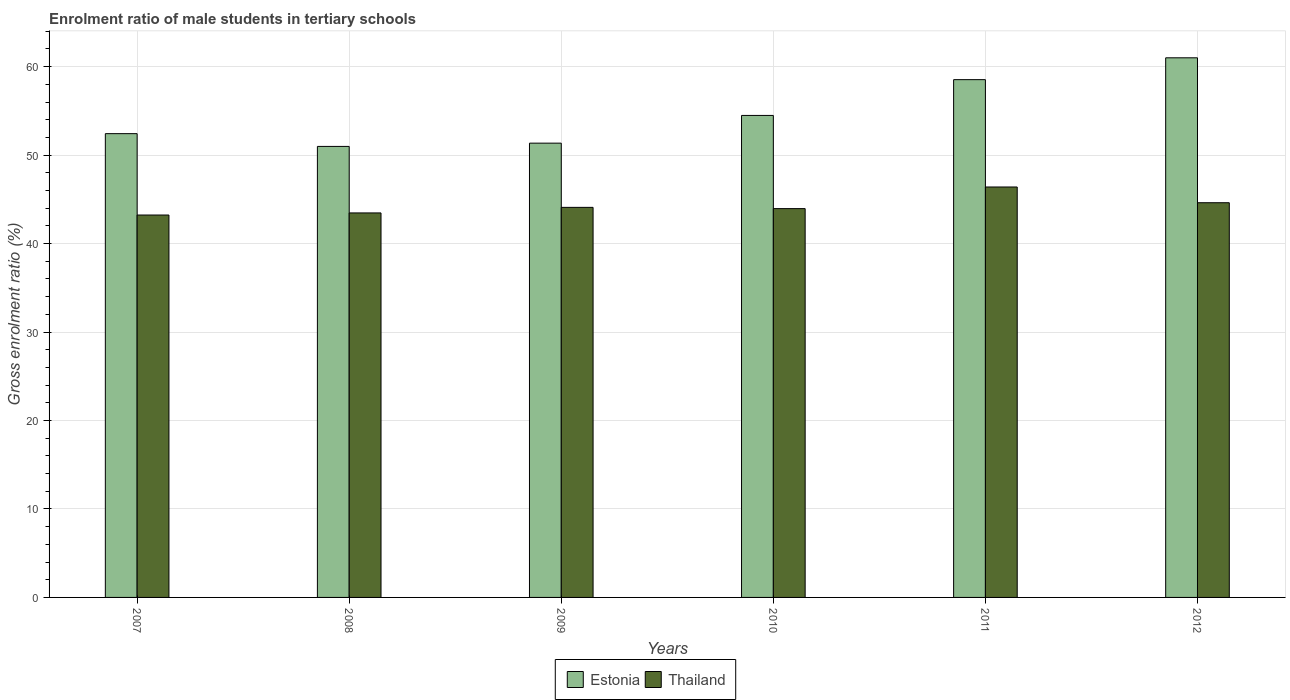How many different coloured bars are there?
Offer a very short reply. 2. Are the number of bars per tick equal to the number of legend labels?
Offer a very short reply. Yes. How many bars are there on the 5th tick from the left?
Offer a very short reply. 2. What is the enrolment ratio of male students in tertiary schools in Thailand in 2012?
Your answer should be very brief. 44.62. Across all years, what is the maximum enrolment ratio of male students in tertiary schools in Thailand?
Your answer should be compact. 46.4. Across all years, what is the minimum enrolment ratio of male students in tertiary schools in Estonia?
Provide a succinct answer. 50.98. In which year was the enrolment ratio of male students in tertiary schools in Thailand maximum?
Offer a terse response. 2011. In which year was the enrolment ratio of male students in tertiary schools in Estonia minimum?
Keep it short and to the point. 2008. What is the total enrolment ratio of male students in tertiary schools in Estonia in the graph?
Ensure brevity in your answer.  328.78. What is the difference between the enrolment ratio of male students in tertiary schools in Estonia in 2008 and that in 2009?
Give a very brief answer. -0.37. What is the difference between the enrolment ratio of male students in tertiary schools in Thailand in 2007 and the enrolment ratio of male students in tertiary schools in Estonia in 2010?
Your answer should be very brief. -11.26. What is the average enrolment ratio of male students in tertiary schools in Thailand per year?
Keep it short and to the point. 44.29. In the year 2011, what is the difference between the enrolment ratio of male students in tertiary schools in Thailand and enrolment ratio of male students in tertiary schools in Estonia?
Provide a succinct answer. -12.13. What is the ratio of the enrolment ratio of male students in tertiary schools in Thailand in 2007 to that in 2010?
Keep it short and to the point. 0.98. Is the enrolment ratio of male students in tertiary schools in Thailand in 2007 less than that in 2011?
Provide a succinct answer. Yes. Is the difference between the enrolment ratio of male students in tertiary schools in Thailand in 2009 and 2011 greater than the difference between the enrolment ratio of male students in tertiary schools in Estonia in 2009 and 2011?
Offer a terse response. Yes. What is the difference between the highest and the second highest enrolment ratio of male students in tertiary schools in Estonia?
Give a very brief answer. 2.47. What is the difference between the highest and the lowest enrolment ratio of male students in tertiary schools in Thailand?
Give a very brief answer. 3.17. In how many years, is the enrolment ratio of male students in tertiary schools in Thailand greater than the average enrolment ratio of male students in tertiary schools in Thailand taken over all years?
Give a very brief answer. 2. Is the sum of the enrolment ratio of male students in tertiary schools in Thailand in 2008 and 2011 greater than the maximum enrolment ratio of male students in tertiary schools in Estonia across all years?
Your answer should be compact. Yes. What does the 2nd bar from the left in 2007 represents?
Make the answer very short. Thailand. What does the 2nd bar from the right in 2010 represents?
Keep it short and to the point. Estonia. How many bars are there?
Provide a short and direct response. 12. What is the difference between two consecutive major ticks on the Y-axis?
Provide a short and direct response. 10. Are the values on the major ticks of Y-axis written in scientific E-notation?
Make the answer very short. No. Where does the legend appear in the graph?
Provide a succinct answer. Bottom center. How many legend labels are there?
Your response must be concise. 2. What is the title of the graph?
Keep it short and to the point. Enrolment ratio of male students in tertiary schools. What is the label or title of the X-axis?
Provide a short and direct response. Years. What is the label or title of the Y-axis?
Your answer should be compact. Gross enrolment ratio (%). What is the Gross enrolment ratio (%) of Estonia in 2007?
Provide a succinct answer. 52.43. What is the Gross enrolment ratio (%) of Thailand in 2007?
Make the answer very short. 43.23. What is the Gross enrolment ratio (%) in Estonia in 2008?
Keep it short and to the point. 50.98. What is the Gross enrolment ratio (%) of Thailand in 2008?
Offer a very short reply. 43.47. What is the Gross enrolment ratio (%) of Estonia in 2009?
Your answer should be compact. 51.35. What is the Gross enrolment ratio (%) in Thailand in 2009?
Offer a very short reply. 44.09. What is the Gross enrolment ratio (%) in Estonia in 2010?
Offer a terse response. 54.49. What is the Gross enrolment ratio (%) in Thailand in 2010?
Make the answer very short. 43.95. What is the Gross enrolment ratio (%) of Estonia in 2011?
Your answer should be compact. 58.53. What is the Gross enrolment ratio (%) of Thailand in 2011?
Your answer should be compact. 46.4. What is the Gross enrolment ratio (%) of Estonia in 2012?
Your answer should be very brief. 61. What is the Gross enrolment ratio (%) in Thailand in 2012?
Give a very brief answer. 44.62. Across all years, what is the maximum Gross enrolment ratio (%) in Estonia?
Your answer should be compact. 61. Across all years, what is the maximum Gross enrolment ratio (%) of Thailand?
Make the answer very short. 46.4. Across all years, what is the minimum Gross enrolment ratio (%) of Estonia?
Your response must be concise. 50.98. Across all years, what is the minimum Gross enrolment ratio (%) of Thailand?
Offer a terse response. 43.23. What is the total Gross enrolment ratio (%) in Estonia in the graph?
Offer a terse response. 328.78. What is the total Gross enrolment ratio (%) in Thailand in the graph?
Give a very brief answer. 265.75. What is the difference between the Gross enrolment ratio (%) in Estonia in 2007 and that in 2008?
Your response must be concise. 1.44. What is the difference between the Gross enrolment ratio (%) of Thailand in 2007 and that in 2008?
Provide a short and direct response. -0.24. What is the difference between the Gross enrolment ratio (%) of Estonia in 2007 and that in 2009?
Ensure brevity in your answer.  1.07. What is the difference between the Gross enrolment ratio (%) in Thailand in 2007 and that in 2009?
Provide a succinct answer. -0.87. What is the difference between the Gross enrolment ratio (%) of Estonia in 2007 and that in 2010?
Keep it short and to the point. -2.06. What is the difference between the Gross enrolment ratio (%) in Thailand in 2007 and that in 2010?
Provide a succinct answer. -0.73. What is the difference between the Gross enrolment ratio (%) of Estonia in 2007 and that in 2011?
Your answer should be very brief. -6.1. What is the difference between the Gross enrolment ratio (%) in Thailand in 2007 and that in 2011?
Provide a succinct answer. -3.17. What is the difference between the Gross enrolment ratio (%) in Estonia in 2007 and that in 2012?
Offer a very short reply. -8.57. What is the difference between the Gross enrolment ratio (%) of Thailand in 2007 and that in 2012?
Offer a very short reply. -1.39. What is the difference between the Gross enrolment ratio (%) in Estonia in 2008 and that in 2009?
Your answer should be very brief. -0.37. What is the difference between the Gross enrolment ratio (%) in Thailand in 2008 and that in 2009?
Give a very brief answer. -0.63. What is the difference between the Gross enrolment ratio (%) of Estonia in 2008 and that in 2010?
Your answer should be compact. -3.5. What is the difference between the Gross enrolment ratio (%) in Thailand in 2008 and that in 2010?
Give a very brief answer. -0.49. What is the difference between the Gross enrolment ratio (%) in Estonia in 2008 and that in 2011?
Offer a very short reply. -7.55. What is the difference between the Gross enrolment ratio (%) of Thailand in 2008 and that in 2011?
Your response must be concise. -2.93. What is the difference between the Gross enrolment ratio (%) of Estonia in 2008 and that in 2012?
Your answer should be very brief. -10.02. What is the difference between the Gross enrolment ratio (%) of Thailand in 2008 and that in 2012?
Your response must be concise. -1.15. What is the difference between the Gross enrolment ratio (%) of Estonia in 2009 and that in 2010?
Ensure brevity in your answer.  -3.13. What is the difference between the Gross enrolment ratio (%) in Thailand in 2009 and that in 2010?
Offer a very short reply. 0.14. What is the difference between the Gross enrolment ratio (%) in Estonia in 2009 and that in 2011?
Your response must be concise. -7.18. What is the difference between the Gross enrolment ratio (%) of Thailand in 2009 and that in 2011?
Provide a succinct answer. -2.3. What is the difference between the Gross enrolment ratio (%) in Estonia in 2009 and that in 2012?
Offer a very short reply. -9.65. What is the difference between the Gross enrolment ratio (%) of Thailand in 2009 and that in 2012?
Offer a very short reply. -0.53. What is the difference between the Gross enrolment ratio (%) in Estonia in 2010 and that in 2011?
Your answer should be very brief. -4.04. What is the difference between the Gross enrolment ratio (%) of Thailand in 2010 and that in 2011?
Ensure brevity in your answer.  -2.44. What is the difference between the Gross enrolment ratio (%) of Estonia in 2010 and that in 2012?
Give a very brief answer. -6.51. What is the difference between the Gross enrolment ratio (%) of Thailand in 2010 and that in 2012?
Keep it short and to the point. -0.67. What is the difference between the Gross enrolment ratio (%) in Estonia in 2011 and that in 2012?
Provide a short and direct response. -2.47. What is the difference between the Gross enrolment ratio (%) of Thailand in 2011 and that in 2012?
Give a very brief answer. 1.78. What is the difference between the Gross enrolment ratio (%) in Estonia in 2007 and the Gross enrolment ratio (%) in Thailand in 2008?
Ensure brevity in your answer.  8.96. What is the difference between the Gross enrolment ratio (%) in Estonia in 2007 and the Gross enrolment ratio (%) in Thailand in 2009?
Keep it short and to the point. 8.33. What is the difference between the Gross enrolment ratio (%) of Estonia in 2007 and the Gross enrolment ratio (%) of Thailand in 2010?
Your answer should be compact. 8.47. What is the difference between the Gross enrolment ratio (%) of Estonia in 2007 and the Gross enrolment ratio (%) of Thailand in 2011?
Your response must be concise. 6.03. What is the difference between the Gross enrolment ratio (%) of Estonia in 2007 and the Gross enrolment ratio (%) of Thailand in 2012?
Offer a very short reply. 7.81. What is the difference between the Gross enrolment ratio (%) in Estonia in 2008 and the Gross enrolment ratio (%) in Thailand in 2009?
Keep it short and to the point. 6.89. What is the difference between the Gross enrolment ratio (%) in Estonia in 2008 and the Gross enrolment ratio (%) in Thailand in 2010?
Keep it short and to the point. 7.03. What is the difference between the Gross enrolment ratio (%) in Estonia in 2008 and the Gross enrolment ratio (%) in Thailand in 2011?
Your response must be concise. 4.59. What is the difference between the Gross enrolment ratio (%) in Estonia in 2008 and the Gross enrolment ratio (%) in Thailand in 2012?
Ensure brevity in your answer.  6.37. What is the difference between the Gross enrolment ratio (%) of Estonia in 2009 and the Gross enrolment ratio (%) of Thailand in 2010?
Offer a terse response. 7.4. What is the difference between the Gross enrolment ratio (%) in Estonia in 2009 and the Gross enrolment ratio (%) in Thailand in 2011?
Offer a terse response. 4.95. What is the difference between the Gross enrolment ratio (%) in Estonia in 2009 and the Gross enrolment ratio (%) in Thailand in 2012?
Offer a terse response. 6.73. What is the difference between the Gross enrolment ratio (%) in Estonia in 2010 and the Gross enrolment ratio (%) in Thailand in 2011?
Give a very brief answer. 8.09. What is the difference between the Gross enrolment ratio (%) in Estonia in 2010 and the Gross enrolment ratio (%) in Thailand in 2012?
Ensure brevity in your answer.  9.87. What is the difference between the Gross enrolment ratio (%) in Estonia in 2011 and the Gross enrolment ratio (%) in Thailand in 2012?
Offer a very short reply. 13.91. What is the average Gross enrolment ratio (%) of Estonia per year?
Your response must be concise. 54.8. What is the average Gross enrolment ratio (%) in Thailand per year?
Ensure brevity in your answer.  44.29. In the year 2007, what is the difference between the Gross enrolment ratio (%) of Estonia and Gross enrolment ratio (%) of Thailand?
Keep it short and to the point. 9.2. In the year 2008, what is the difference between the Gross enrolment ratio (%) of Estonia and Gross enrolment ratio (%) of Thailand?
Give a very brief answer. 7.52. In the year 2009, what is the difference between the Gross enrolment ratio (%) in Estonia and Gross enrolment ratio (%) in Thailand?
Offer a very short reply. 7.26. In the year 2010, what is the difference between the Gross enrolment ratio (%) in Estonia and Gross enrolment ratio (%) in Thailand?
Provide a succinct answer. 10.53. In the year 2011, what is the difference between the Gross enrolment ratio (%) of Estonia and Gross enrolment ratio (%) of Thailand?
Keep it short and to the point. 12.13. In the year 2012, what is the difference between the Gross enrolment ratio (%) of Estonia and Gross enrolment ratio (%) of Thailand?
Provide a succinct answer. 16.38. What is the ratio of the Gross enrolment ratio (%) of Estonia in 2007 to that in 2008?
Your answer should be compact. 1.03. What is the ratio of the Gross enrolment ratio (%) of Estonia in 2007 to that in 2009?
Provide a succinct answer. 1.02. What is the ratio of the Gross enrolment ratio (%) of Thailand in 2007 to that in 2009?
Make the answer very short. 0.98. What is the ratio of the Gross enrolment ratio (%) in Estonia in 2007 to that in 2010?
Offer a terse response. 0.96. What is the ratio of the Gross enrolment ratio (%) in Thailand in 2007 to that in 2010?
Ensure brevity in your answer.  0.98. What is the ratio of the Gross enrolment ratio (%) of Estonia in 2007 to that in 2011?
Make the answer very short. 0.9. What is the ratio of the Gross enrolment ratio (%) of Thailand in 2007 to that in 2011?
Make the answer very short. 0.93. What is the ratio of the Gross enrolment ratio (%) in Estonia in 2007 to that in 2012?
Keep it short and to the point. 0.86. What is the ratio of the Gross enrolment ratio (%) in Thailand in 2007 to that in 2012?
Your answer should be very brief. 0.97. What is the ratio of the Gross enrolment ratio (%) of Estonia in 2008 to that in 2009?
Give a very brief answer. 0.99. What is the ratio of the Gross enrolment ratio (%) in Thailand in 2008 to that in 2009?
Give a very brief answer. 0.99. What is the ratio of the Gross enrolment ratio (%) in Estonia in 2008 to that in 2010?
Your response must be concise. 0.94. What is the ratio of the Gross enrolment ratio (%) of Thailand in 2008 to that in 2010?
Give a very brief answer. 0.99. What is the ratio of the Gross enrolment ratio (%) of Estonia in 2008 to that in 2011?
Ensure brevity in your answer.  0.87. What is the ratio of the Gross enrolment ratio (%) in Thailand in 2008 to that in 2011?
Make the answer very short. 0.94. What is the ratio of the Gross enrolment ratio (%) of Estonia in 2008 to that in 2012?
Keep it short and to the point. 0.84. What is the ratio of the Gross enrolment ratio (%) in Thailand in 2008 to that in 2012?
Keep it short and to the point. 0.97. What is the ratio of the Gross enrolment ratio (%) of Estonia in 2009 to that in 2010?
Keep it short and to the point. 0.94. What is the ratio of the Gross enrolment ratio (%) in Thailand in 2009 to that in 2010?
Ensure brevity in your answer.  1. What is the ratio of the Gross enrolment ratio (%) in Estonia in 2009 to that in 2011?
Give a very brief answer. 0.88. What is the ratio of the Gross enrolment ratio (%) of Thailand in 2009 to that in 2011?
Your response must be concise. 0.95. What is the ratio of the Gross enrolment ratio (%) of Estonia in 2009 to that in 2012?
Keep it short and to the point. 0.84. What is the ratio of the Gross enrolment ratio (%) of Thailand in 2009 to that in 2012?
Keep it short and to the point. 0.99. What is the ratio of the Gross enrolment ratio (%) of Estonia in 2010 to that in 2011?
Keep it short and to the point. 0.93. What is the ratio of the Gross enrolment ratio (%) of Thailand in 2010 to that in 2011?
Provide a succinct answer. 0.95. What is the ratio of the Gross enrolment ratio (%) of Estonia in 2010 to that in 2012?
Offer a very short reply. 0.89. What is the ratio of the Gross enrolment ratio (%) in Thailand in 2010 to that in 2012?
Your answer should be compact. 0.99. What is the ratio of the Gross enrolment ratio (%) in Estonia in 2011 to that in 2012?
Your answer should be very brief. 0.96. What is the ratio of the Gross enrolment ratio (%) of Thailand in 2011 to that in 2012?
Your answer should be compact. 1.04. What is the difference between the highest and the second highest Gross enrolment ratio (%) in Estonia?
Give a very brief answer. 2.47. What is the difference between the highest and the second highest Gross enrolment ratio (%) in Thailand?
Your answer should be compact. 1.78. What is the difference between the highest and the lowest Gross enrolment ratio (%) of Estonia?
Make the answer very short. 10.02. What is the difference between the highest and the lowest Gross enrolment ratio (%) of Thailand?
Your answer should be compact. 3.17. 